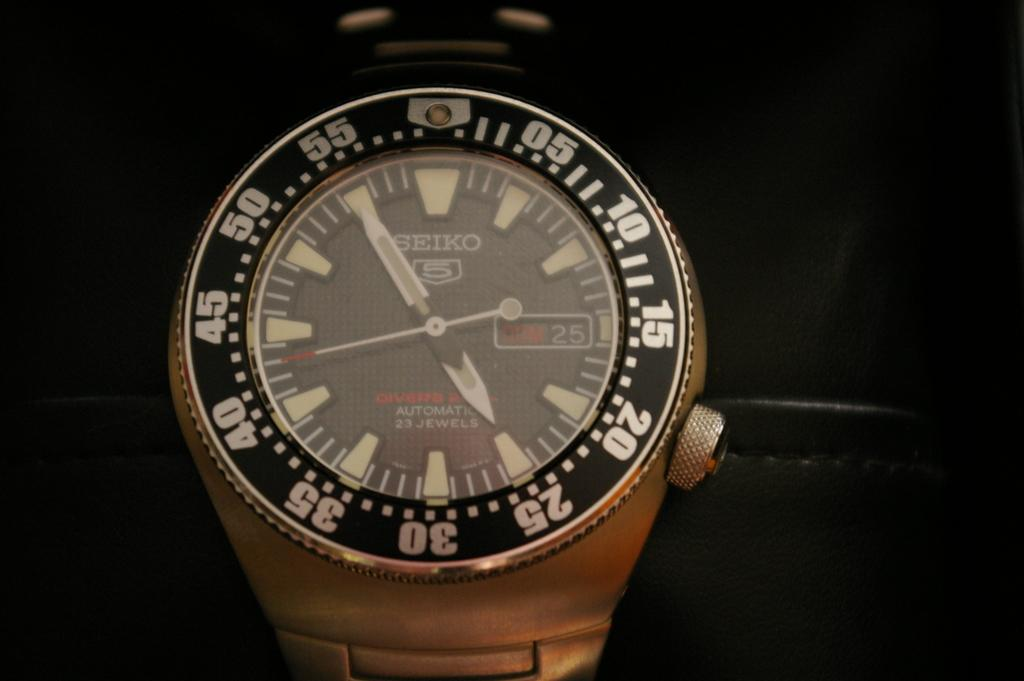Provide a one-sentence caption for the provided image. A silver and black watch says "SEIKO" on the face. 